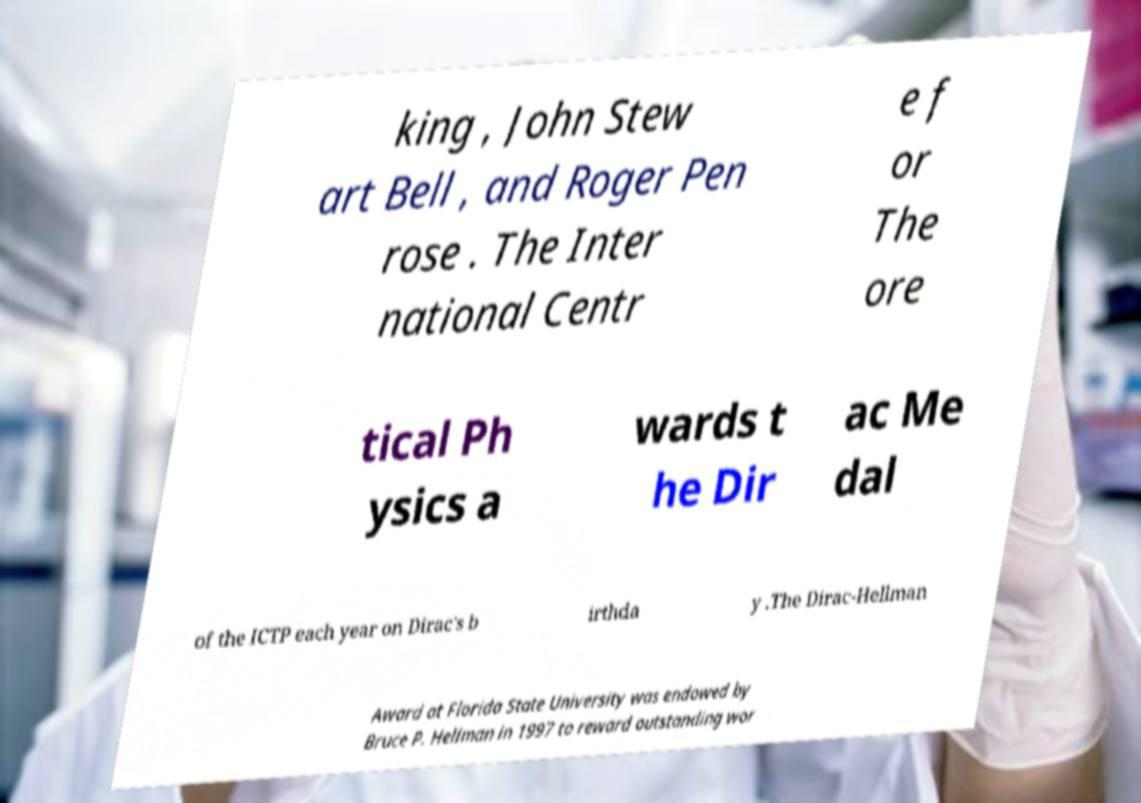Please identify and transcribe the text found in this image. king , John Stew art Bell , and Roger Pen rose . The Inter national Centr e f or The ore tical Ph ysics a wards t he Dir ac Me dal of the ICTP each year on Dirac's b irthda y .The Dirac-Hellman Award at Florida State University was endowed by Bruce P. Hellman in 1997 to reward outstanding wor 